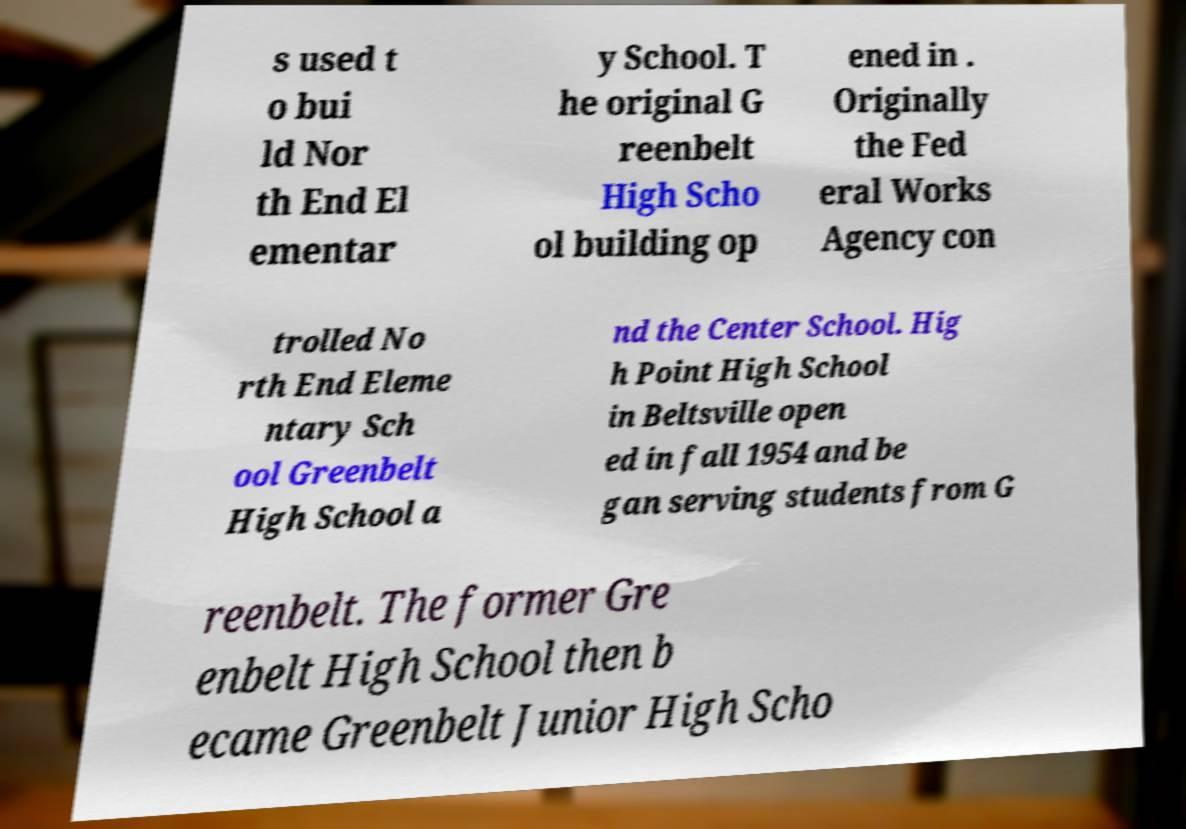I need the written content from this picture converted into text. Can you do that? s used t o bui ld Nor th End El ementar y School. T he original G reenbelt High Scho ol building op ened in . Originally the Fed eral Works Agency con trolled No rth End Eleme ntary Sch ool Greenbelt High School a nd the Center School. Hig h Point High School in Beltsville open ed in fall 1954 and be gan serving students from G reenbelt. The former Gre enbelt High School then b ecame Greenbelt Junior High Scho 